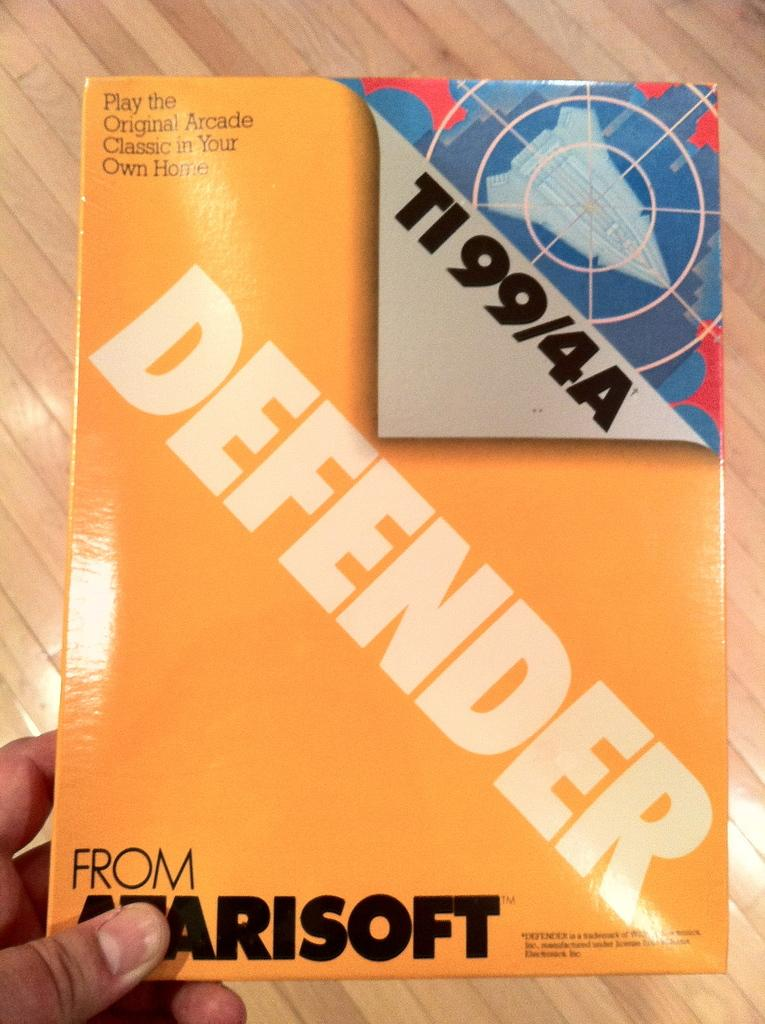<image>
Share a concise interpretation of the image provided. hand holding yellow box containing defender for ti99/4a 